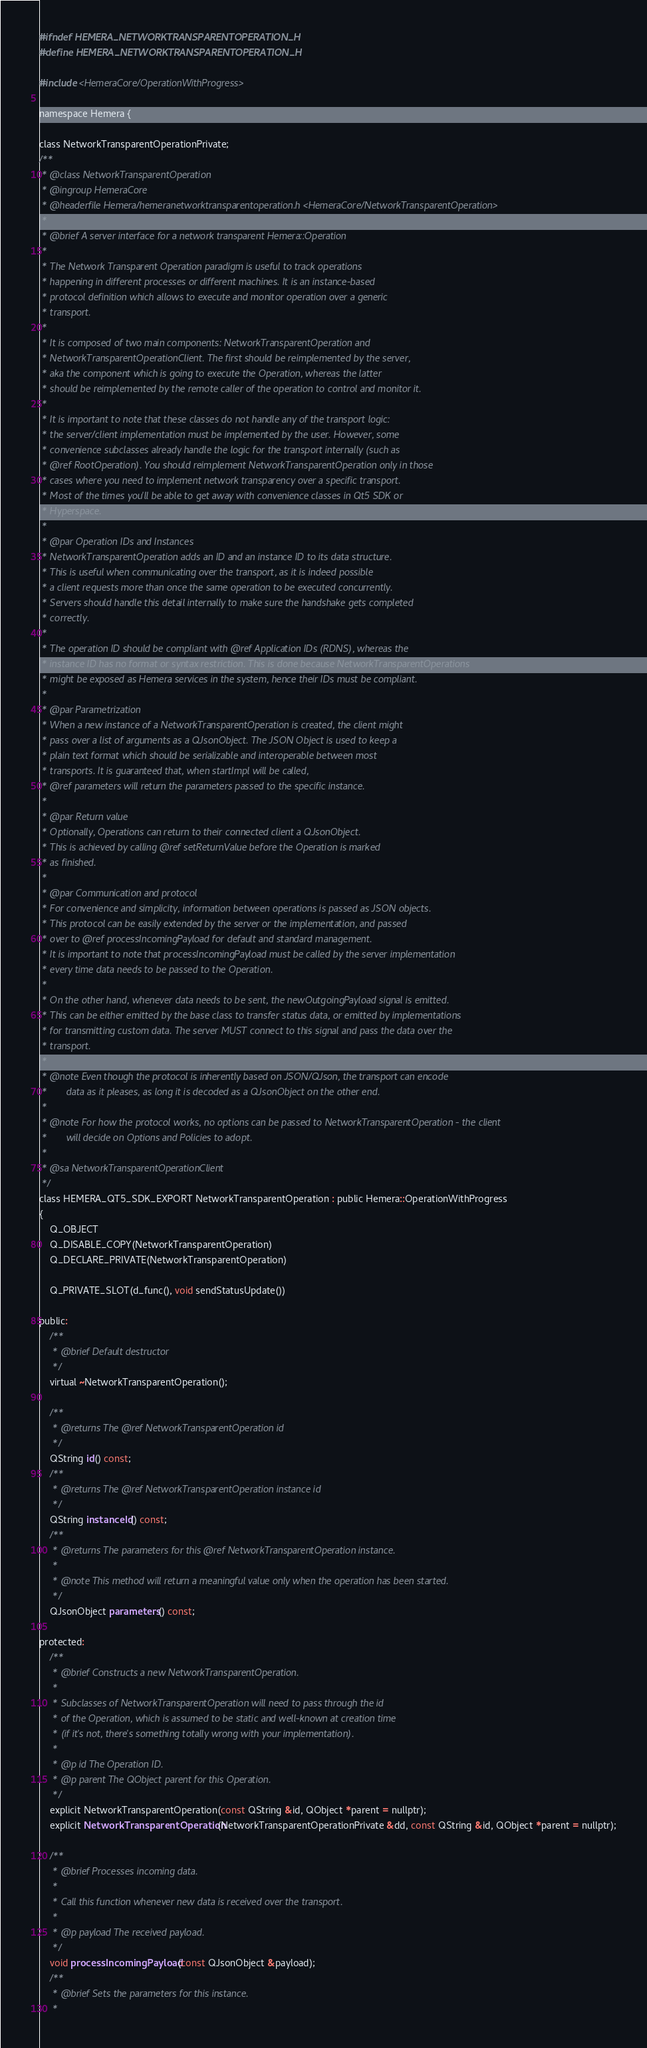Convert code to text. <code><loc_0><loc_0><loc_500><loc_500><_C_>#ifndef HEMERA_NETWORKTRANSPARENTOPERATION_H
#define HEMERA_NETWORKTRANSPARENTOPERATION_H

#include <HemeraCore/OperationWithProgress>

namespace Hemera {

class NetworkTransparentOperationPrivate;
/**
 * @class NetworkTransparentOperation
 * @ingroup HemeraCore
 * @headerfile Hemera/hemeranetworktransparentoperation.h <HemeraCore/NetworkTransparentOperation>
 *
 * @brief A server interface for a network transparent Hemera::Operation
 *
 * The Network Transparent Operation paradigm is useful to track operations
 * happening in different processes or different machines. It is an instance-based
 * protocol definition which allows to execute and monitor operation over a generic
 * transport.
 *
 * It is composed of two main components: NetworkTransparentOperation and
 * NetworkTransparentOperationClient. The first should be reimplemented by the server,
 * aka the component which is going to execute the Operation, whereas the latter
 * should be reimplemented by the remote caller of the operation to control and monitor it.
 *
 * It is important to note that these classes do not handle any of the transport logic:
 * the server/client implementation must be implemented by the user. However, some
 * convenience subclasses already handle the logic for the transport internally (such as
 * @ref RootOperation). You should reimplement NetworkTransparentOperation only in those
 * cases where you need to implement network transparency over a specific transport.
 * Most of the times you'll be able to get away with convenience classes in Qt5 SDK or
 * Hyperspace.
 *
 * @par Operation IDs and Instances
 * NetworkTransparentOperation adds an ID and an instance ID to its data structure.
 * This is useful when communicating over the transport, as it is indeed possible
 * a client requests more than once the same operation to be executed concurrently.
 * Servers should handle this detail internally to make sure the handshake gets completed
 * correctly.
 *
 * The operation ID should be compliant with @ref Application IDs (RDNS), whereas the
 * instance ID has no format or syntax restriction. This is done because NetworkTransparentOperations
 * might be exposed as Hemera services in the system, hence their IDs must be compliant.
 *
 * @par Parametrization
 * When a new instance of a NetworkTransparentOperation is created, the client might
 * pass over a list of arguments as a QJsonObject. The JSON Object is used to keep a
 * plain text format which should be serializable and interoperable between most
 * transports. It is guaranteed that, when startImpl will be called,
 * @ref parameters will return the parameters passed to the specific instance.
 *
 * @par Return value
 * Optionally, Operations can return to their connected client a QJsonObject.
 * This is achieved by calling @ref setReturnValue before the Operation is marked
 * as finished.
 *
 * @par Communication and protocol
 * For convenience and simplicity, information between operations is passed as JSON objects.
 * This protocol can be easily extended by the server or the implementation, and passed
 * over to @ref processIncomingPayload for default and standard management.
 * It is important to note that processIncomingPayload must be called by the server implementation
 * every time data needs to be passed to the Operation.
 *
 * On the other hand, whenever data needs to be sent, the newOutgoingPayload signal is emitted.
 * This can be either emitted by the base class to transfer status data, or emitted by implementations
 * for transmitting custom data. The server MUST connect to this signal and pass the data over the
 * transport.
 *
 * @note Even though the protocol is inherently based on JSON/QJson, the transport can encode
 *       data as it pleases, as long it is decoded as a QJsonObject on the other end.
 *
 * @note For how the protocol works, no options can be passed to NetworkTransparentOperation - the client
 *       will decide on Options and Policies to adopt.
 *
 * @sa NetworkTransparentOperationClient
 */
class HEMERA_QT5_SDK_EXPORT NetworkTransparentOperation : public Hemera::OperationWithProgress
{
    Q_OBJECT
    Q_DISABLE_COPY(NetworkTransparentOperation)
    Q_DECLARE_PRIVATE(NetworkTransparentOperation)

    Q_PRIVATE_SLOT(d_func(), void sendStatusUpdate())

public:
    /**
     * @brief Default destructor
     */
    virtual ~NetworkTransparentOperation();

    /**
     * @returns The @ref NetworkTransparentOperation id
     */
    QString id() const;
    /**
     * @returns The @ref NetworkTransparentOperation instance id
     */
    QString instanceId() const;
    /**
     * @returns The parameters for this @ref NetworkTransparentOperation instance.
     *
     * @note This method will return a meaningful value only when the operation has been started.
     */
    QJsonObject parameters() const;

protected:
    /**
     * @brief Constructs a new NetworkTransparentOperation.
     *
     * Subclasses of NetworkTransparentOperation will need to pass through the id
     * of the Operation, which is assumed to be static and well-known at creation time
     * (if it's not, there's something totally wrong with your implementation).
     *
     * @p id The Operation ID.
     * @p parent The QObject parent for this Operation.
     */
    explicit NetworkTransparentOperation(const QString &id, QObject *parent = nullptr);
    explicit NetworkTransparentOperation(NetworkTransparentOperationPrivate &dd, const QString &id, QObject *parent = nullptr);

    /**
     * @brief Processes incoming data.
     *
     * Call this function whenever new data is received over the transport.
     *
     * @p payload The received payload.
     */
    void processIncomingPayload(const QJsonObject &payload);
    /**
     * @brief Sets the parameters for this instance.
     *</code> 